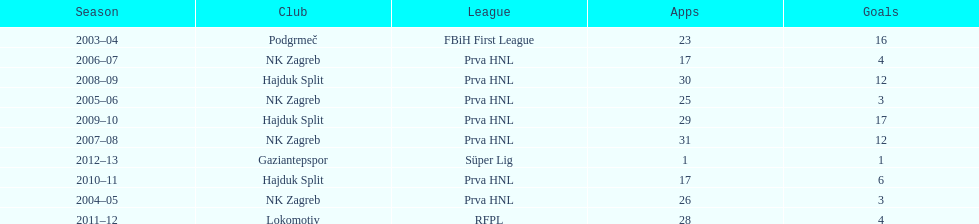At most 26 apps, how many goals were scored in 2004-2005 3. 